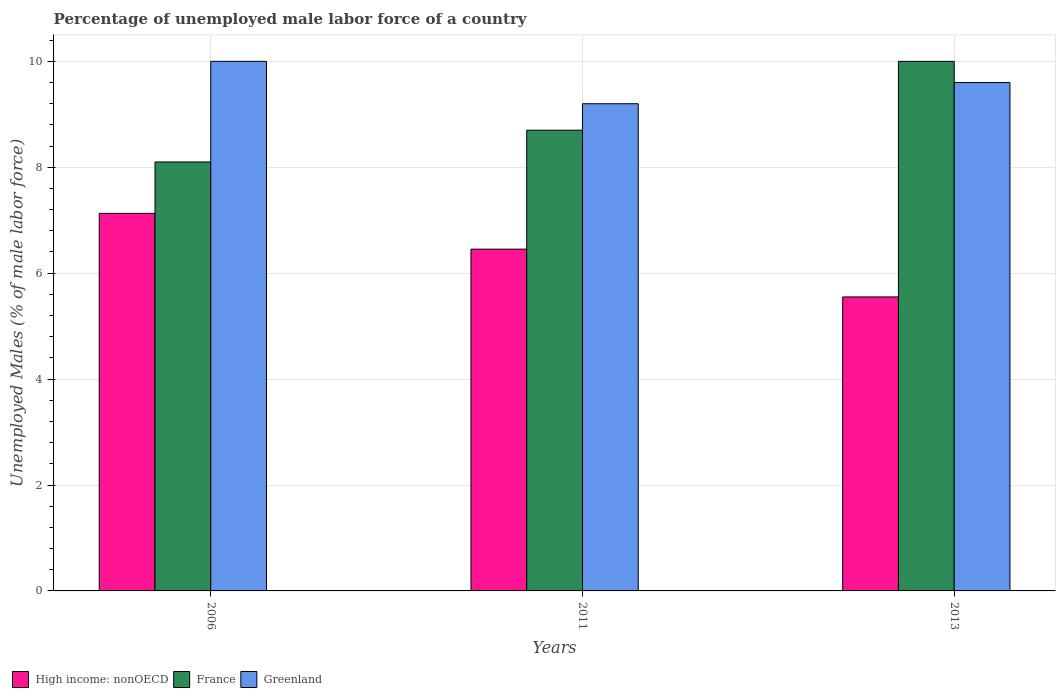How many different coloured bars are there?
Offer a terse response. 3. Are the number of bars on each tick of the X-axis equal?
Provide a succinct answer. Yes. How many bars are there on the 1st tick from the left?
Keep it short and to the point. 3. How many bars are there on the 1st tick from the right?
Your answer should be very brief. 3. What is the label of the 2nd group of bars from the left?
Keep it short and to the point. 2011. What is the percentage of unemployed male labor force in Greenland in 2011?
Offer a terse response. 9.2. Across all years, what is the maximum percentage of unemployed male labor force in Greenland?
Ensure brevity in your answer.  10. Across all years, what is the minimum percentage of unemployed male labor force in France?
Your answer should be compact. 8.1. In which year was the percentage of unemployed male labor force in France maximum?
Give a very brief answer. 2013. What is the total percentage of unemployed male labor force in Greenland in the graph?
Your answer should be compact. 28.8. What is the difference between the percentage of unemployed male labor force in Greenland in 2011 and that in 2013?
Your answer should be very brief. -0.4. What is the difference between the percentage of unemployed male labor force in High income: nonOECD in 2006 and the percentage of unemployed male labor force in Greenland in 2013?
Ensure brevity in your answer.  -2.47. What is the average percentage of unemployed male labor force in High income: nonOECD per year?
Provide a short and direct response. 6.38. In the year 2006, what is the difference between the percentage of unemployed male labor force in High income: nonOECD and percentage of unemployed male labor force in France?
Offer a terse response. -0.97. In how many years, is the percentage of unemployed male labor force in France greater than 9.2 %?
Provide a short and direct response. 1. What is the ratio of the percentage of unemployed male labor force in France in 2006 to that in 2011?
Provide a succinct answer. 0.93. Is the percentage of unemployed male labor force in France in 2011 less than that in 2013?
Ensure brevity in your answer.  Yes. Is the difference between the percentage of unemployed male labor force in High income: nonOECD in 2011 and 2013 greater than the difference between the percentage of unemployed male labor force in France in 2011 and 2013?
Your response must be concise. Yes. What is the difference between the highest and the second highest percentage of unemployed male labor force in France?
Your answer should be compact. 1.3. What is the difference between the highest and the lowest percentage of unemployed male labor force in France?
Your response must be concise. 1.9. What does the 2nd bar from the right in 2006 represents?
Make the answer very short. France. How many bars are there?
Offer a very short reply. 9. Are all the bars in the graph horizontal?
Make the answer very short. No. How many years are there in the graph?
Provide a short and direct response. 3. Does the graph contain grids?
Provide a succinct answer. Yes. How many legend labels are there?
Give a very brief answer. 3. How are the legend labels stacked?
Offer a very short reply. Horizontal. What is the title of the graph?
Your response must be concise. Percentage of unemployed male labor force of a country. Does "Saudi Arabia" appear as one of the legend labels in the graph?
Ensure brevity in your answer.  No. What is the label or title of the X-axis?
Make the answer very short. Years. What is the label or title of the Y-axis?
Offer a very short reply. Unemployed Males (% of male labor force). What is the Unemployed Males (% of male labor force) in High income: nonOECD in 2006?
Your answer should be compact. 7.13. What is the Unemployed Males (% of male labor force) of France in 2006?
Your response must be concise. 8.1. What is the Unemployed Males (% of male labor force) in High income: nonOECD in 2011?
Your response must be concise. 6.45. What is the Unemployed Males (% of male labor force) of France in 2011?
Offer a terse response. 8.7. What is the Unemployed Males (% of male labor force) in Greenland in 2011?
Offer a very short reply. 9.2. What is the Unemployed Males (% of male labor force) in High income: nonOECD in 2013?
Your answer should be compact. 5.55. What is the Unemployed Males (% of male labor force) in France in 2013?
Offer a terse response. 10. What is the Unemployed Males (% of male labor force) in Greenland in 2013?
Your answer should be compact. 9.6. Across all years, what is the maximum Unemployed Males (% of male labor force) in High income: nonOECD?
Make the answer very short. 7.13. Across all years, what is the minimum Unemployed Males (% of male labor force) of High income: nonOECD?
Ensure brevity in your answer.  5.55. Across all years, what is the minimum Unemployed Males (% of male labor force) in France?
Make the answer very short. 8.1. Across all years, what is the minimum Unemployed Males (% of male labor force) in Greenland?
Offer a very short reply. 9.2. What is the total Unemployed Males (% of male labor force) of High income: nonOECD in the graph?
Make the answer very short. 19.13. What is the total Unemployed Males (% of male labor force) of France in the graph?
Ensure brevity in your answer.  26.8. What is the total Unemployed Males (% of male labor force) in Greenland in the graph?
Offer a terse response. 28.8. What is the difference between the Unemployed Males (% of male labor force) in High income: nonOECD in 2006 and that in 2011?
Give a very brief answer. 0.68. What is the difference between the Unemployed Males (% of male labor force) of France in 2006 and that in 2011?
Provide a short and direct response. -0.6. What is the difference between the Unemployed Males (% of male labor force) of High income: nonOECD in 2006 and that in 2013?
Offer a very short reply. 1.58. What is the difference between the Unemployed Males (% of male labor force) in France in 2006 and that in 2013?
Offer a very short reply. -1.9. What is the difference between the Unemployed Males (% of male labor force) in High income: nonOECD in 2011 and that in 2013?
Make the answer very short. 0.9. What is the difference between the Unemployed Males (% of male labor force) in France in 2011 and that in 2013?
Provide a succinct answer. -1.3. What is the difference between the Unemployed Males (% of male labor force) in High income: nonOECD in 2006 and the Unemployed Males (% of male labor force) in France in 2011?
Give a very brief answer. -1.57. What is the difference between the Unemployed Males (% of male labor force) in High income: nonOECD in 2006 and the Unemployed Males (% of male labor force) in Greenland in 2011?
Offer a very short reply. -2.07. What is the difference between the Unemployed Males (% of male labor force) of High income: nonOECD in 2006 and the Unemployed Males (% of male labor force) of France in 2013?
Your response must be concise. -2.87. What is the difference between the Unemployed Males (% of male labor force) in High income: nonOECD in 2006 and the Unemployed Males (% of male labor force) in Greenland in 2013?
Your answer should be very brief. -2.47. What is the difference between the Unemployed Males (% of male labor force) of France in 2006 and the Unemployed Males (% of male labor force) of Greenland in 2013?
Provide a short and direct response. -1.5. What is the difference between the Unemployed Males (% of male labor force) in High income: nonOECD in 2011 and the Unemployed Males (% of male labor force) in France in 2013?
Provide a succinct answer. -3.55. What is the difference between the Unemployed Males (% of male labor force) in High income: nonOECD in 2011 and the Unemployed Males (% of male labor force) in Greenland in 2013?
Your response must be concise. -3.15. What is the difference between the Unemployed Males (% of male labor force) of France in 2011 and the Unemployed Males (% of male labor force) of Greenland in 2013?
Keep it short and to the point. -0.9. What is the average Unemployed Males (% of male labor force) in High income: nonOECD per year?
Provide a short and direct response. 6.38. What is the average Unemployed Males (% of male labor force) in France per year?
Give a very brief answer. 8.93. What is the average Unemployed Males (% of male labor force) in Greenland per year?
Give a very brief answer. 9.6. In the year 2006, what is the difference between the Unemployed Males (% of male labor force) in High income: nonOECD and Unemployed Males (% of male labor force) in France?
Your answer should be compact. -0.97. In the year 2006, what is the difference between the Unemployed Males (% of male labor force) of High income: nonOECD and Unemployed Males (% of male labor force) of Greenland?
Provide a short and direct response. -2.87. In the year 2011, what is the difference between the Unemployed Males (% of male labor force) in High income: nonOECD and Unemployed Males (% of male labor force) in France?
Make the answer very short. -2.25. In the year 2011, what is the difference between the Unemployed Males (% of male labor force) of High income: nonOECD and Unemployed Males (% of male labor force) of Greenland?
Your answer should be compact. -2.75. In the year 2011, what is the difference between the Unemployed Males (% of male labor force) of France and Unemployed Males (% of male labor force) of Greenland?
Provide a succinct answer. -0.5. In the year 2013, what is the difference between the Unemployed Males (% of male labor force) in High income: nonOECD and Unemployed Males (% of male labor force) in France?
Give a very brief answer. -4.45. In the year 2013, what is the difference between the Unemployed Males (% of male labor force) in High income: nonOECD and Unemployed Males (% of male labor force) in Greenland?
Give a very brief answer. -4.05. What is the ratio of the Unemployed Males (% of male labor force) in High income: nonOECD in 2006 to that in 2011?
Keep it short and to the point. 1.1. What is the ratio of the Unemployed Males (% of male labor force) of Greenland in 2006 to that in 2011?
Provide a succinct answer. 1.09. What is the ratio of the Unemployed Males (% of male labor force) in High income: nonOECD in 2006 to that in 2013?
Your answer should be very brief. 1.28. What is the ratio of the Unemployed Males (% of male labor force) of France in 2006 to that in 2013?
Ensure brevity in your answer.  0.81. What is the ratio of the Unemployed Males (% of male labor force) in Greenland in 2006 to that in 2013?
Make the answer very short. 1.04. What is the ratio of the Unemployed Males (% of male labor force) in High income: nonOECD in 2011 to that in 2013?
Ensure brevity in your answer.  1.16. What is the ratio of the Unemployed Males (% of male labor force) of France in 2011 to that in 2013?
Offer a very short reply. 0.87. What is the ratio of the Unemployed Males (% of male labor force) in Greenland in 2011 to that in 2013?
Ensure brevity in your answer.  0.96. What is the difference between the highest and the second highest Unemployed Males (% of male labor force) in High income: nonOECD?
Offer a terse response. 0.68. What is the difference between the highest and the second highest Unemployed Males (% of male labor force) of France?
Offer a terse response. 1.3. What is the difference between the highest and the lowest Unemployed Males (% of male labor force) in High income: nonOECD?
Offer a terse response. 1.58. What is the difference between the highest and the lowest Unemployed Males (% of male labor force) of Greenland?
Your response must be concise. 0.8. 